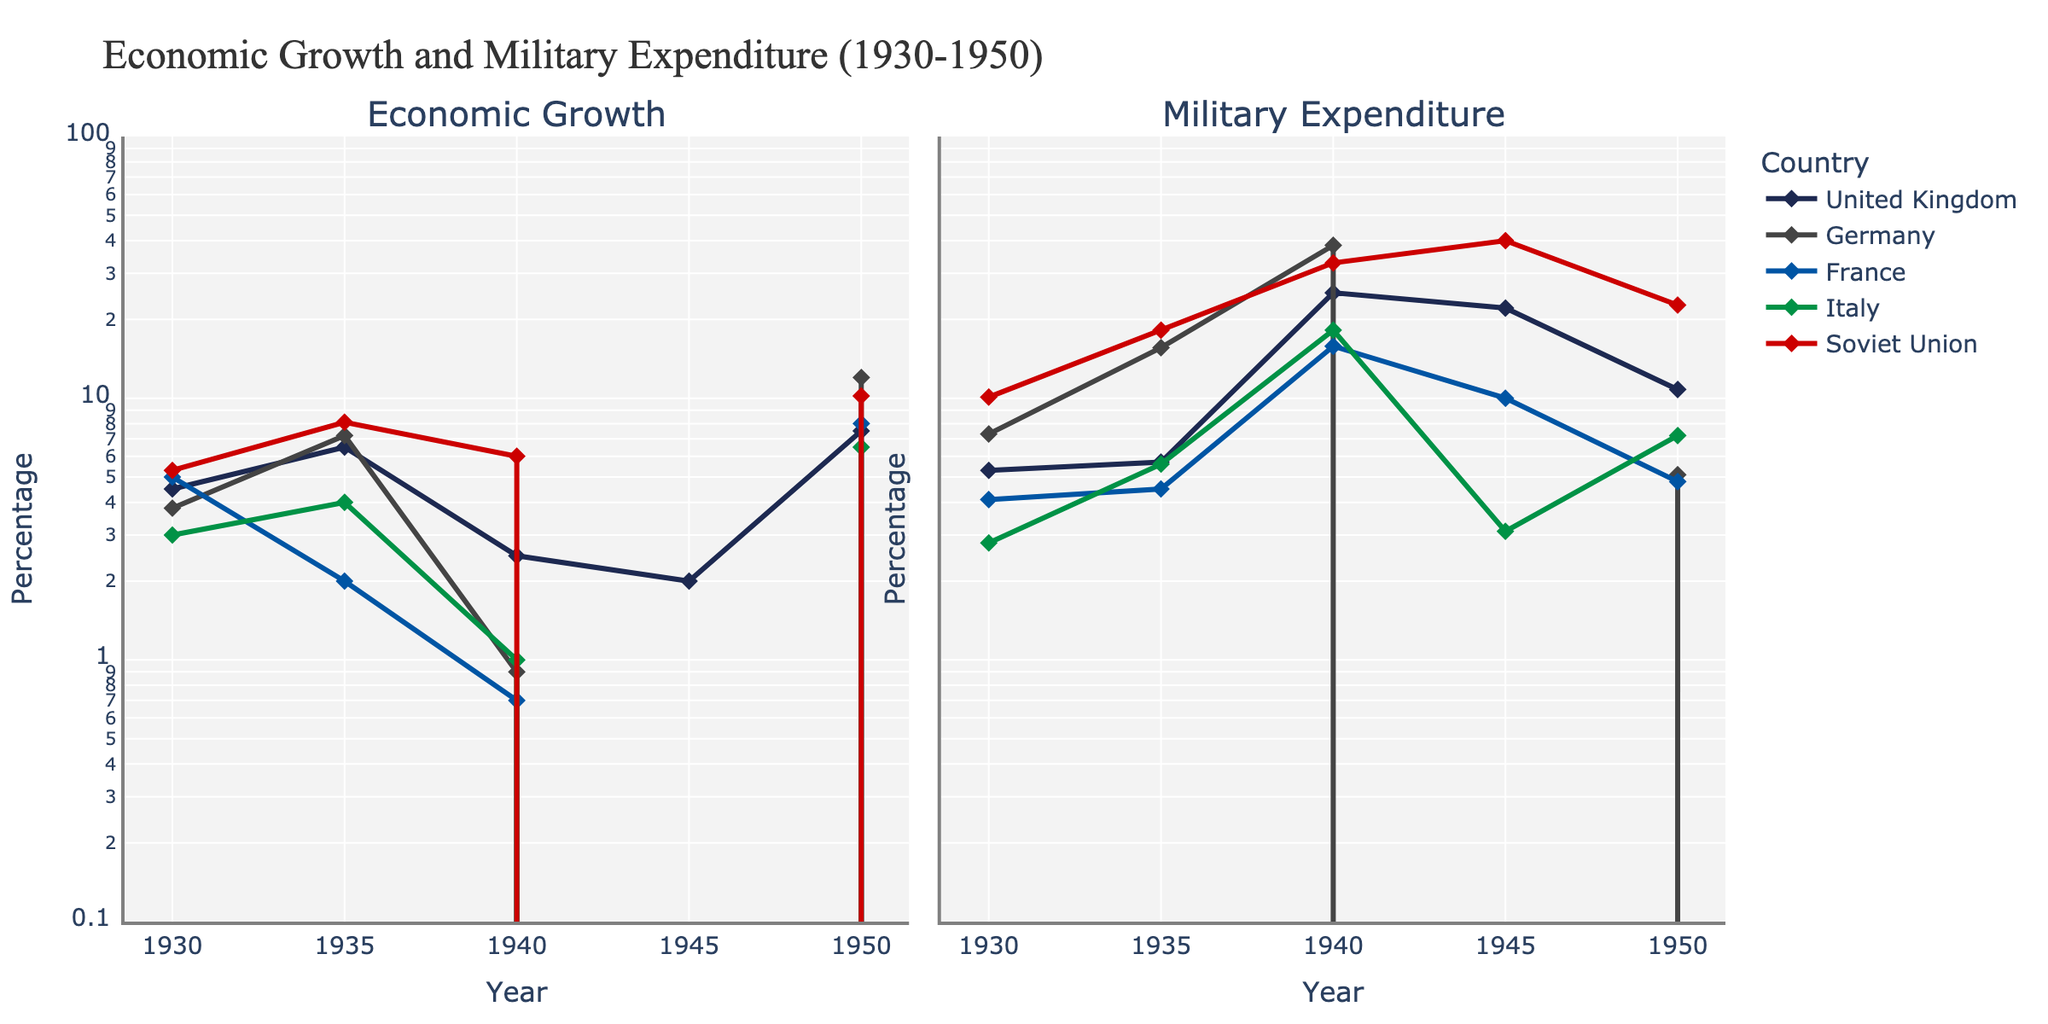What are the highest and lowest points of economic growth for the United Kingdom between 1930 and 1950? The highest point for the United Kingdom's economic growth is at 1950 with 7.5, and the lowest point is at 1945 with 2.0
Answer: Highest: 7.5, Lowest: 2.0 Which country had the highest military expenditure in 1940? By examining the military expenditure lines for each country in 1940, Germany had the highest value with a significant 38.4.
Answer: Germany What was Germany's economic growth in 1945, and how did it compare to the previous years? Germany's economic growth in 1945 was -11.0, a sharp decline from 0.9 in 1940 and 7.2 in 1935, indicating severe economic downturn due to WWII.
Answer: -11.0, significant decline How does Soviet Union's military expenditure in 1950 compare to its military expenditure in 1930? In 1950, the Soviet Union's military expenditure was 22.7 which is more than double of its military expenditure of 10.1 in 1930.
Answer: More than double Which country exhibited the highest economic growth in 1950? Comparing the data points for economic growth in 1950 across all countries, Germany had the highest economic growth at 12.0.
Answer: Germany How did France's military expenditure in 1940 compare to its military expenditure in 1935? France's military expenditure increased significantly from 4.5 in 1935 to 15.8 in 1940.
Answer: Increase What is the trend in Italy's economic growth from 1930 to 1950? Italy's economic growth shows an initial increase from 1930 (3.0) to 1935 (4.0), a decline around WWII to -5.5 in 1945, followed by recovery to 6.5 in 1950.
Answer: Fluctuating with recovery Did any country experience a negative economic growth in 1945? In 1945, both Germany and Italy experienced negative economic growth with values of -11.0 and -5.5, respectively.
Answer: Germany and Italy Which countries had their peak military expenditures during WWII? Both Germany and the Soviet Union reached their peak military expenditures during WWII, marked in 1940 at 38.4 and 32.9, respectively.
Answer: Germany and Soviet Union 